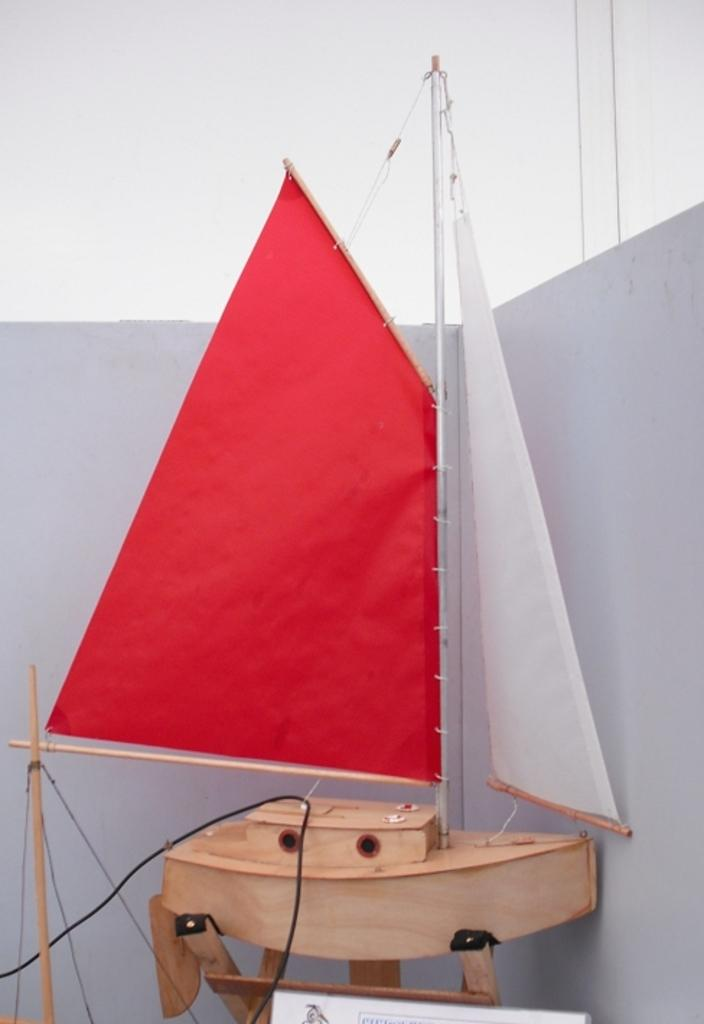What type of toy is in the image? There is a ship toy in the image. What material is the ship toy made of? The ship toy is made of wood. How is the ship toy positioned in the image? The ship toy is on a stand. What is behind the stand in the image? The stand is before a wall. What is visible at the top of the image? A: The sky is visible at the top of the image. How many chickens are on the ship toy in the image? There are no chickens present on the ship toy in the image; it is made of wood and does not have any animals on it. 